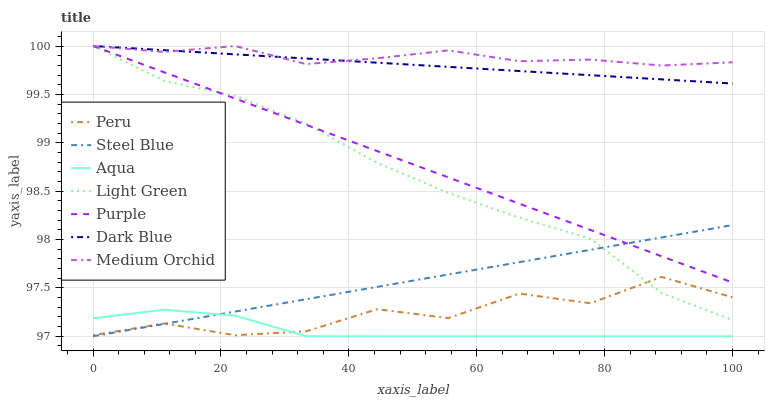Does Aqua have the minimum area under the curve?
Answer yes or no. Yes. Does Medium Orchid have the maximum area under the curve?
Answer yes or no. Yes. Does Purple have the minimum area under the curve?
Answer yes or no. No. Does Purple have the maximum area under the curve?
Answer yes or no. No. Is Steel Blue the smoothest?
Answer yes or no. Yes. Is Peru the roughest?
Answer yes or no. Yes. Is Purple the smoothest?
Answer yes or no. No. Is Purple the roughest?
Answer yes or no. No. Does Aqua have the lowest value?
Answer yes or no. Yes. Does Purple have the lowest value?
Answer yes or no. No. Does Light Green have the highest value?
Answer yes or no. Yes. Does Aqua have the highest value?
Answer yes or no. No. Is Peru less than Purple?
Answer yes or no. Yes. Is Dark Blue greater than Peru?
Answer yes or no. Yes. Does Light Green intersect Dark Blue?
Answer yes or no. Yes. Is Light Green less than Dark Blue?
Answer yes or no. No. Is Light Green greater than Dark Blue?
Answer yes or no. No. Does Peru intersect Purple?
Answer yes or no. No. 